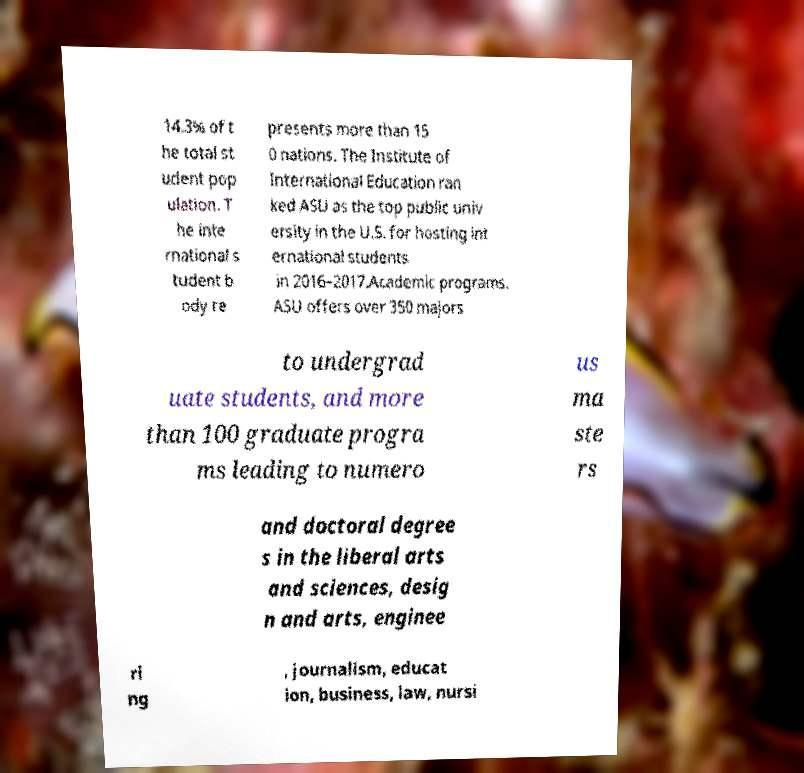I need the written content from this picture converted into text. Can you do that? 14.3% of t he total st udent pop ulation. T he inte rnational s tudent b ody re presents more than 15 0 nations. The Institute of International Education ran ked ASU as the top public univ ersity in the U.S. for hosting int ernational students in 2016–2017.Academic programs. ASU offers over 350 majors to undergrad uate students, and more than 100 graduate progra ms leading to numero us ma ste rs and doctoral degree s in the liberal arts and sciences, desig n and arts, enginee ri ng , journalism, educat ion, business, law, nursi 